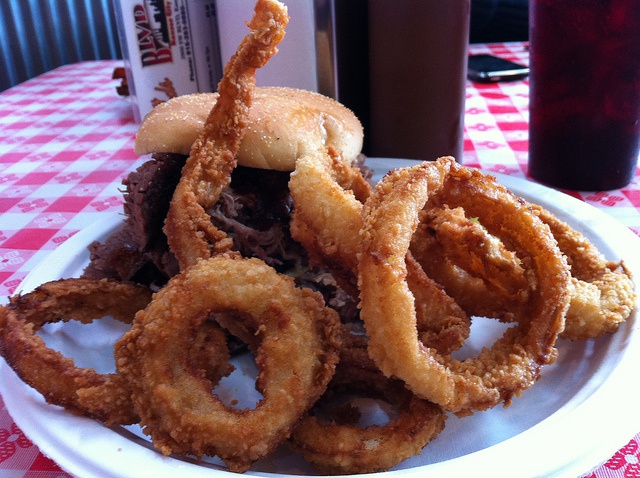Describe the objects in this image and their specific colors. I can see dining table in darkblue, violet, and lavender tones, cup in darkblue, black, purple, and navy tones, cup in darkblue, black, and purple tones, and cell phone in darkblue, black, navy, white, and purple tones in this image. 